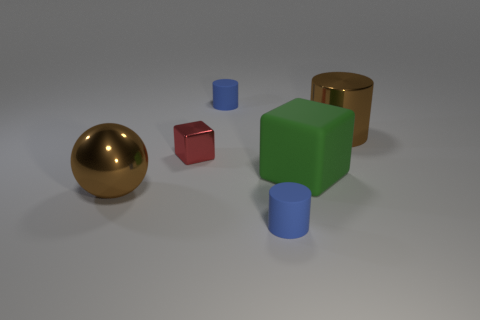Add 1 matte cylinders. How many objects exist? 7 Subtract all blocks. How many objects are left? 4 Subtract all tiny shiny cylinders. Subtract all blue cylinders. How many objects are left? 4 Add 4 tiny matte cylinders. How many tiny matte cylinders are left? 6 Add 1 small rubber balls. How many small rubber balls exist? 1 Subtract 0 purple spheres. How many objects are left? 6 